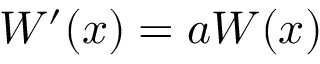Convert formula to latex. <formula><loc_0><loc_0><loc_500><loc_500>W ^ { \prime } ( x ) = a W ( x )</formula> 